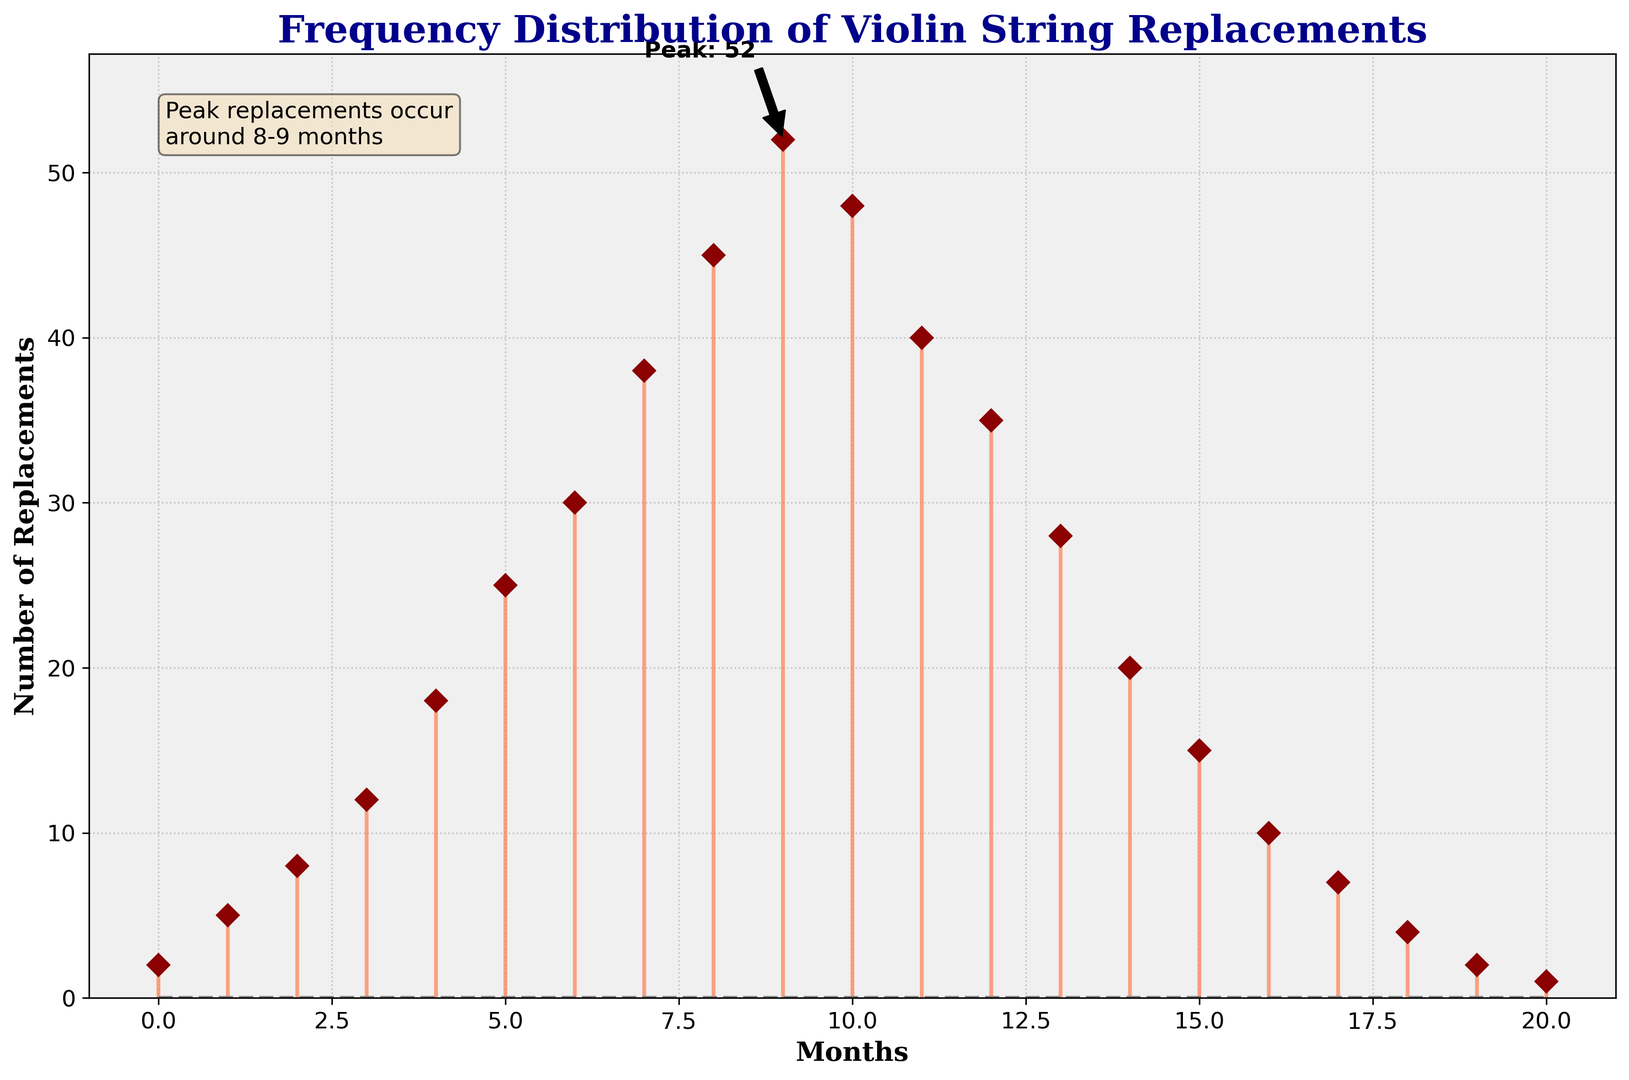what's the month with the highest number of replacements? The peak month is found by locating the highest point on the stem plot. According to the annotation on the plot, the peak replacements occur in the 9th month.
Answer: 9 how many more replacements are there in the 9th month compared to the 1st month? Identify the replacements in the 9th month and the 1st month and compute the difference: 52 - 5 = 47.
Answer: 47 what's the total number of replacements in the first half of the year? Sum the replacements for the first six months (0 to 5): 2 + 5 + 8 + 12 + 18 + 25 = 70.
Answer: 70 what's the average number of replacements after the peak month? Calculate the average replacements from months 10 to 20: (48 + 40 + 35 + 28 + 20 + 15 + 10 + 7 + 4 + 2 + 1) / 11 = 21.
Answer: 21 which month shows a sudden increase in the number of replacements compared to the previous month? Look for a steep rise between consecutive months; the number jumps significantly from 30 replacements in month 6 to 38 in month 7.
Answer: 7 in which month do replacements first exceed 30? Identify the month where replacement count first goes above 30; this happens in the 7th month.
Answer: 7 how does the number of replacements change from month 8 to month 9? Compare the number of replacements in months 8 and 9: 52 (month 9) - 45 (month 8) = 7, indicating an increase of 7 replacements.
Answer: 7 what's the color of the peak annotation in the figure? Identify the color of the text label for the peak month, which is visually indicated as black.
Answer: black what's the difference in replacements between month 13 and month 17? Calculate the difference by subtracting the values: 28 (month 13) - 7 (month 17) = 21.
Answer: 21 what's the replacement count in the last month, and how does it compare to the initial month? Compare the counts in the 20th and 0th months: 1 (month 20) vs. 2 (month 0).
Answer: month 20: 1, month 0: 2 